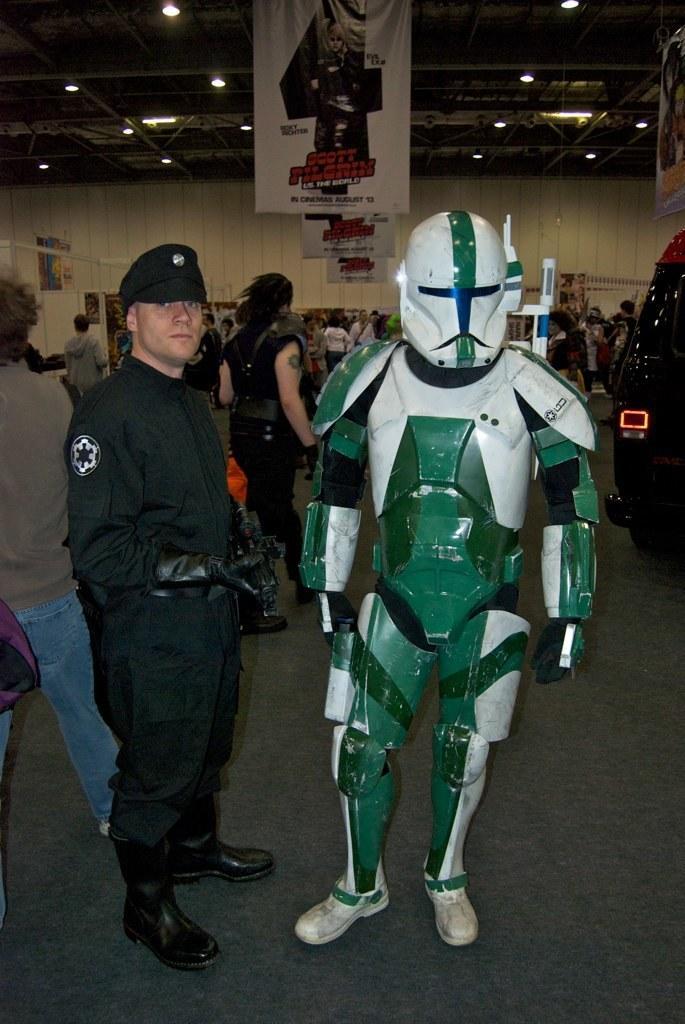In one or two sentences, can you explain what this image depicts? In this image there are some persons standing in middle of this image and there is one person wearing a robot dress as we can see on the right side of this image, and there is a wall in the background. There are some advertising boards and some lights are arranged on the top of this image. 